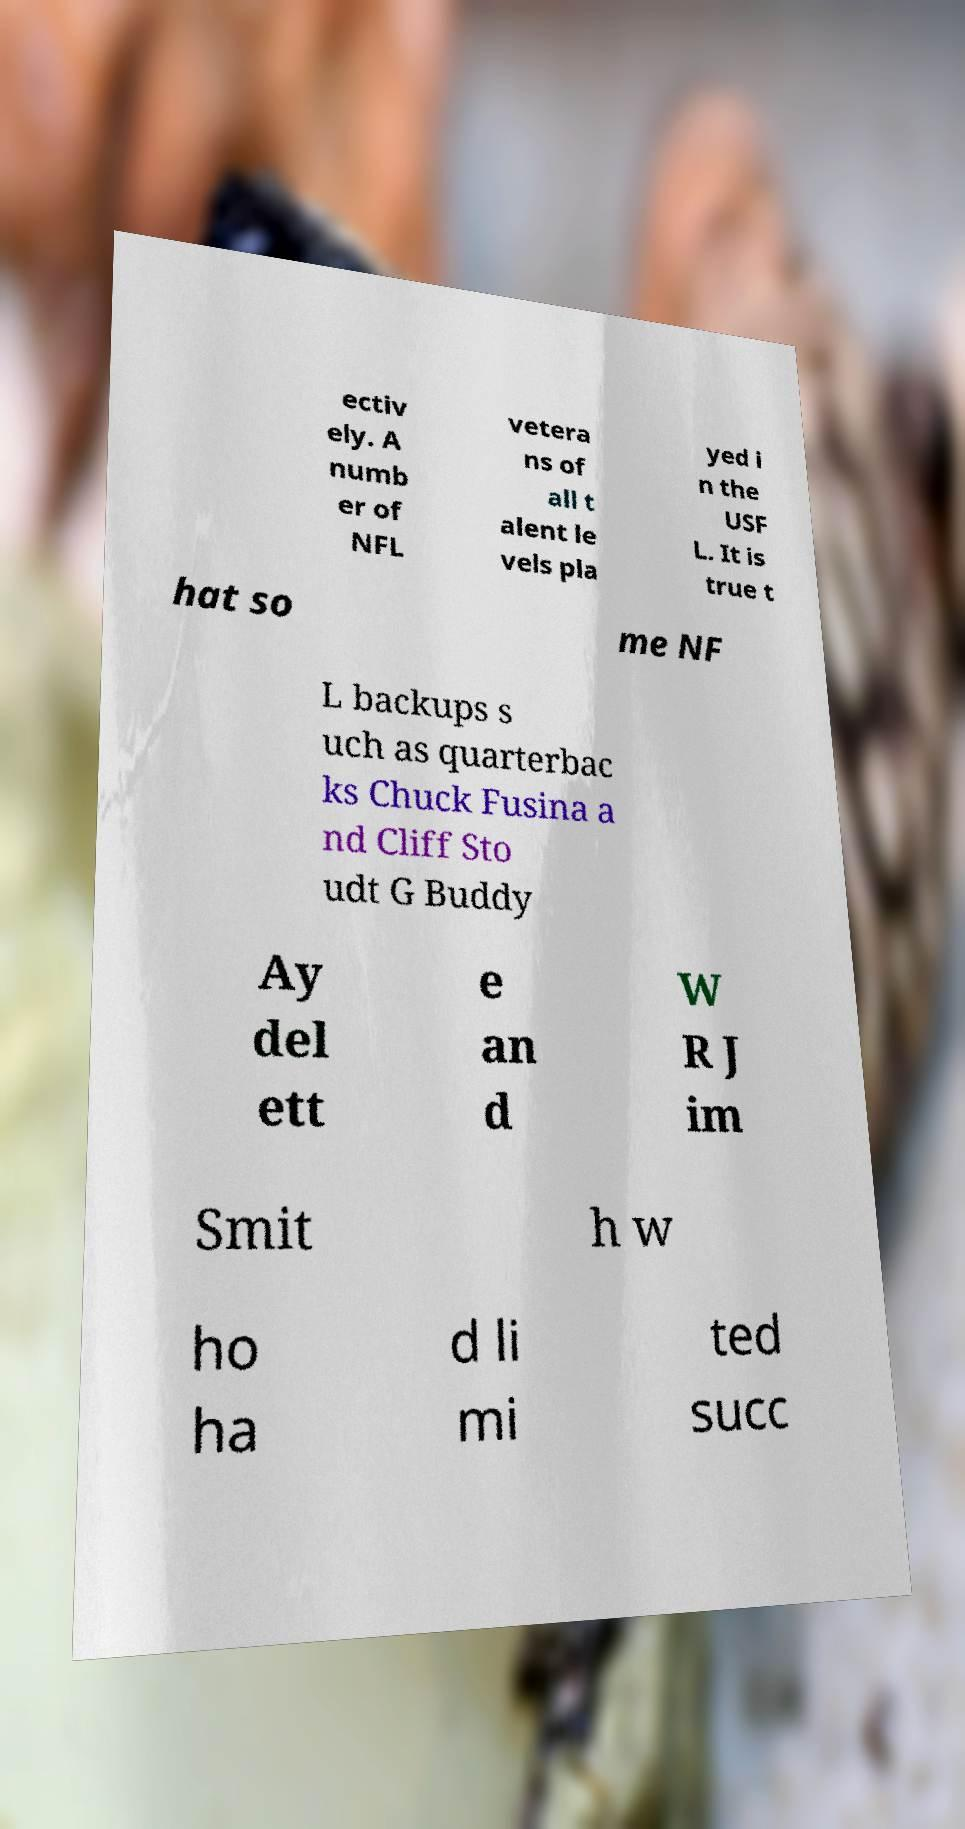There's text embedded in this image that I need extracted. Can you transcribe it verbatim? ectiv ely. A numb er of NFL vetera ns of all t alent le vels pla yed i n the USF L. It is true t hat so me NF L backups s uch as quarterbac ks Chuck Fusina a nd Cliff Sto udt G Buddy Ay del ett e an d W R J im Smit h w ho ha d li mi ted succ 